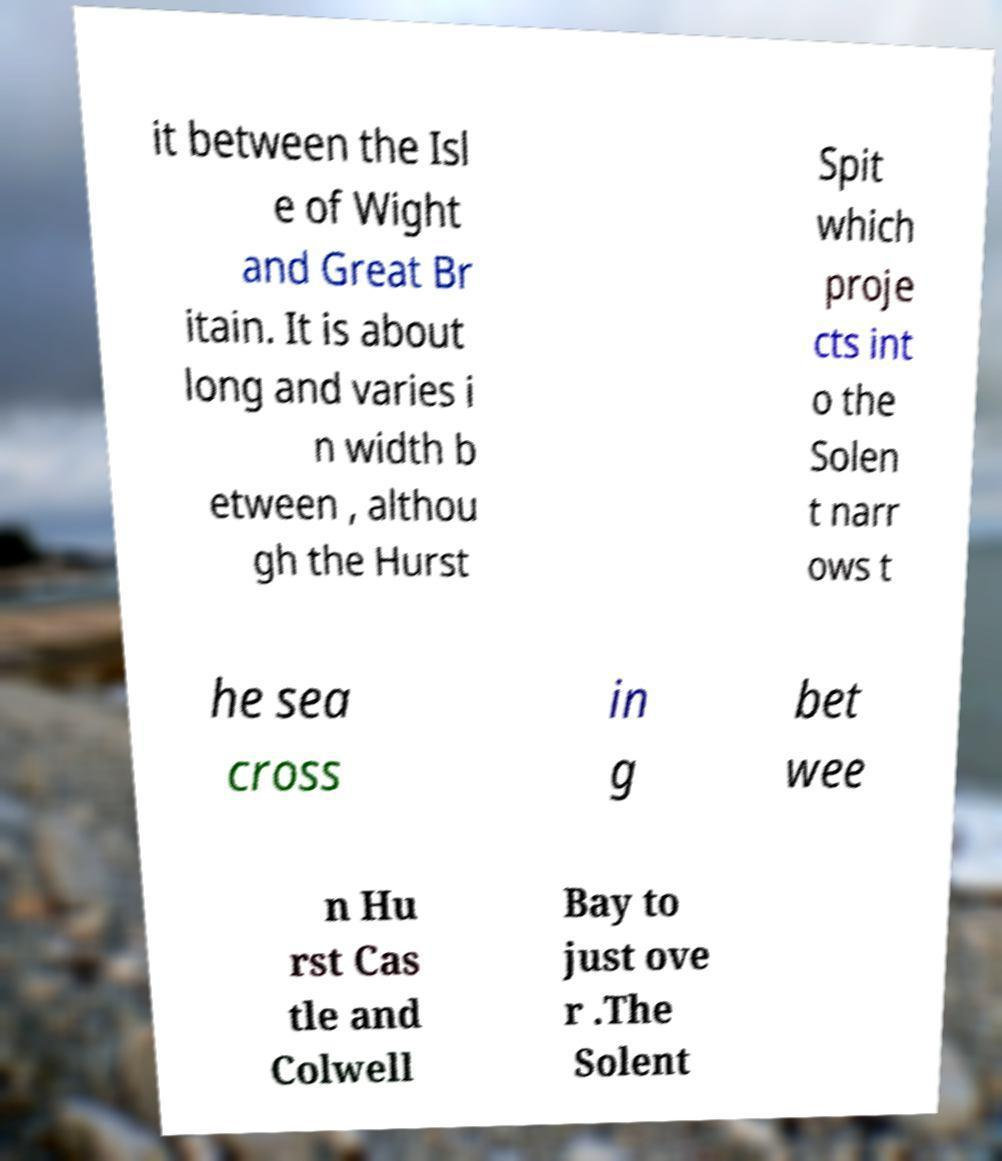For documentation purposes, I need the text within this image transcribed. Could you provide that? it between the Isl e of Wight and Great Br itain. It is about long and varies i n width b etween , althou gh the Hurst Spit which proje cts int o the Solen t narr ows t he sea cross in g bet wee n Hu rst Cas tle and Colwell Bay to just ove r .The Solent 